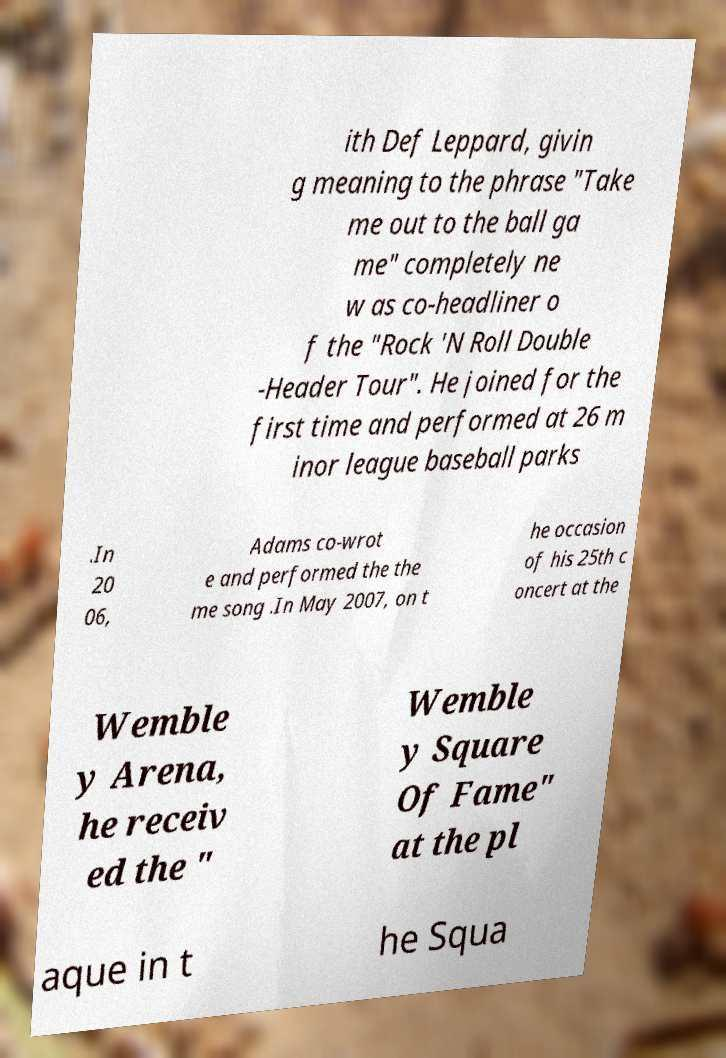Please read and relay the text visible in this image. What does it say? ith Def Leppard, givin g meaning to the phrase "Take me out to the ball ga me" completely ne w as co-headliner o f the "Rock 'N Roll Double -Header Tour". He joined for the first time and performed at 26 m inor league baseball parks .In 20 06, Adams co-wrot e and performed the the me song .In May 2007, on t he occasion of his 25th c oncert at the Wemble y Arena, he receiv ed the " Wemble y Square Of Fame" at the pl aque in t he Squa 